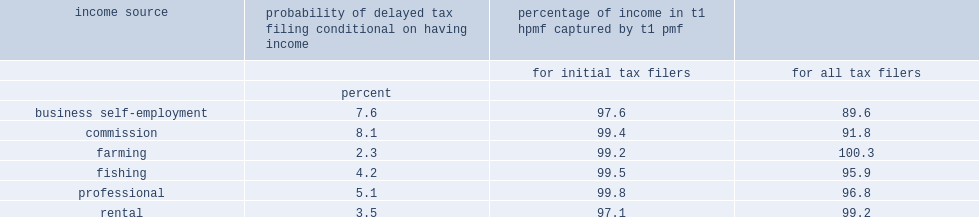What was the proportion of individuals with commission income delayed filing over the years considered? 8.1. Under-represented in the t1 pmf, what was the proportion of individuals with business self-employment considered to be initial tax filers? 97.6. Under-represented in the t1 pmf, what was the proportion of individuals with rental incomes considered to be initial tax filers? 97.1. 